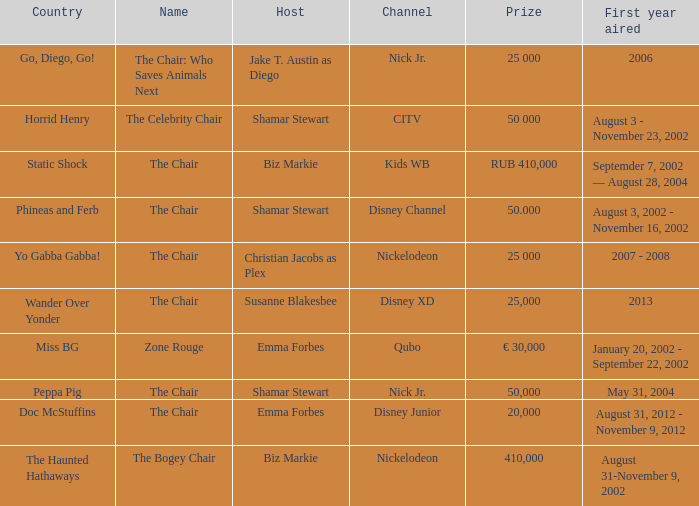What was the host of Horrid Henry? Shamar Stewart. 